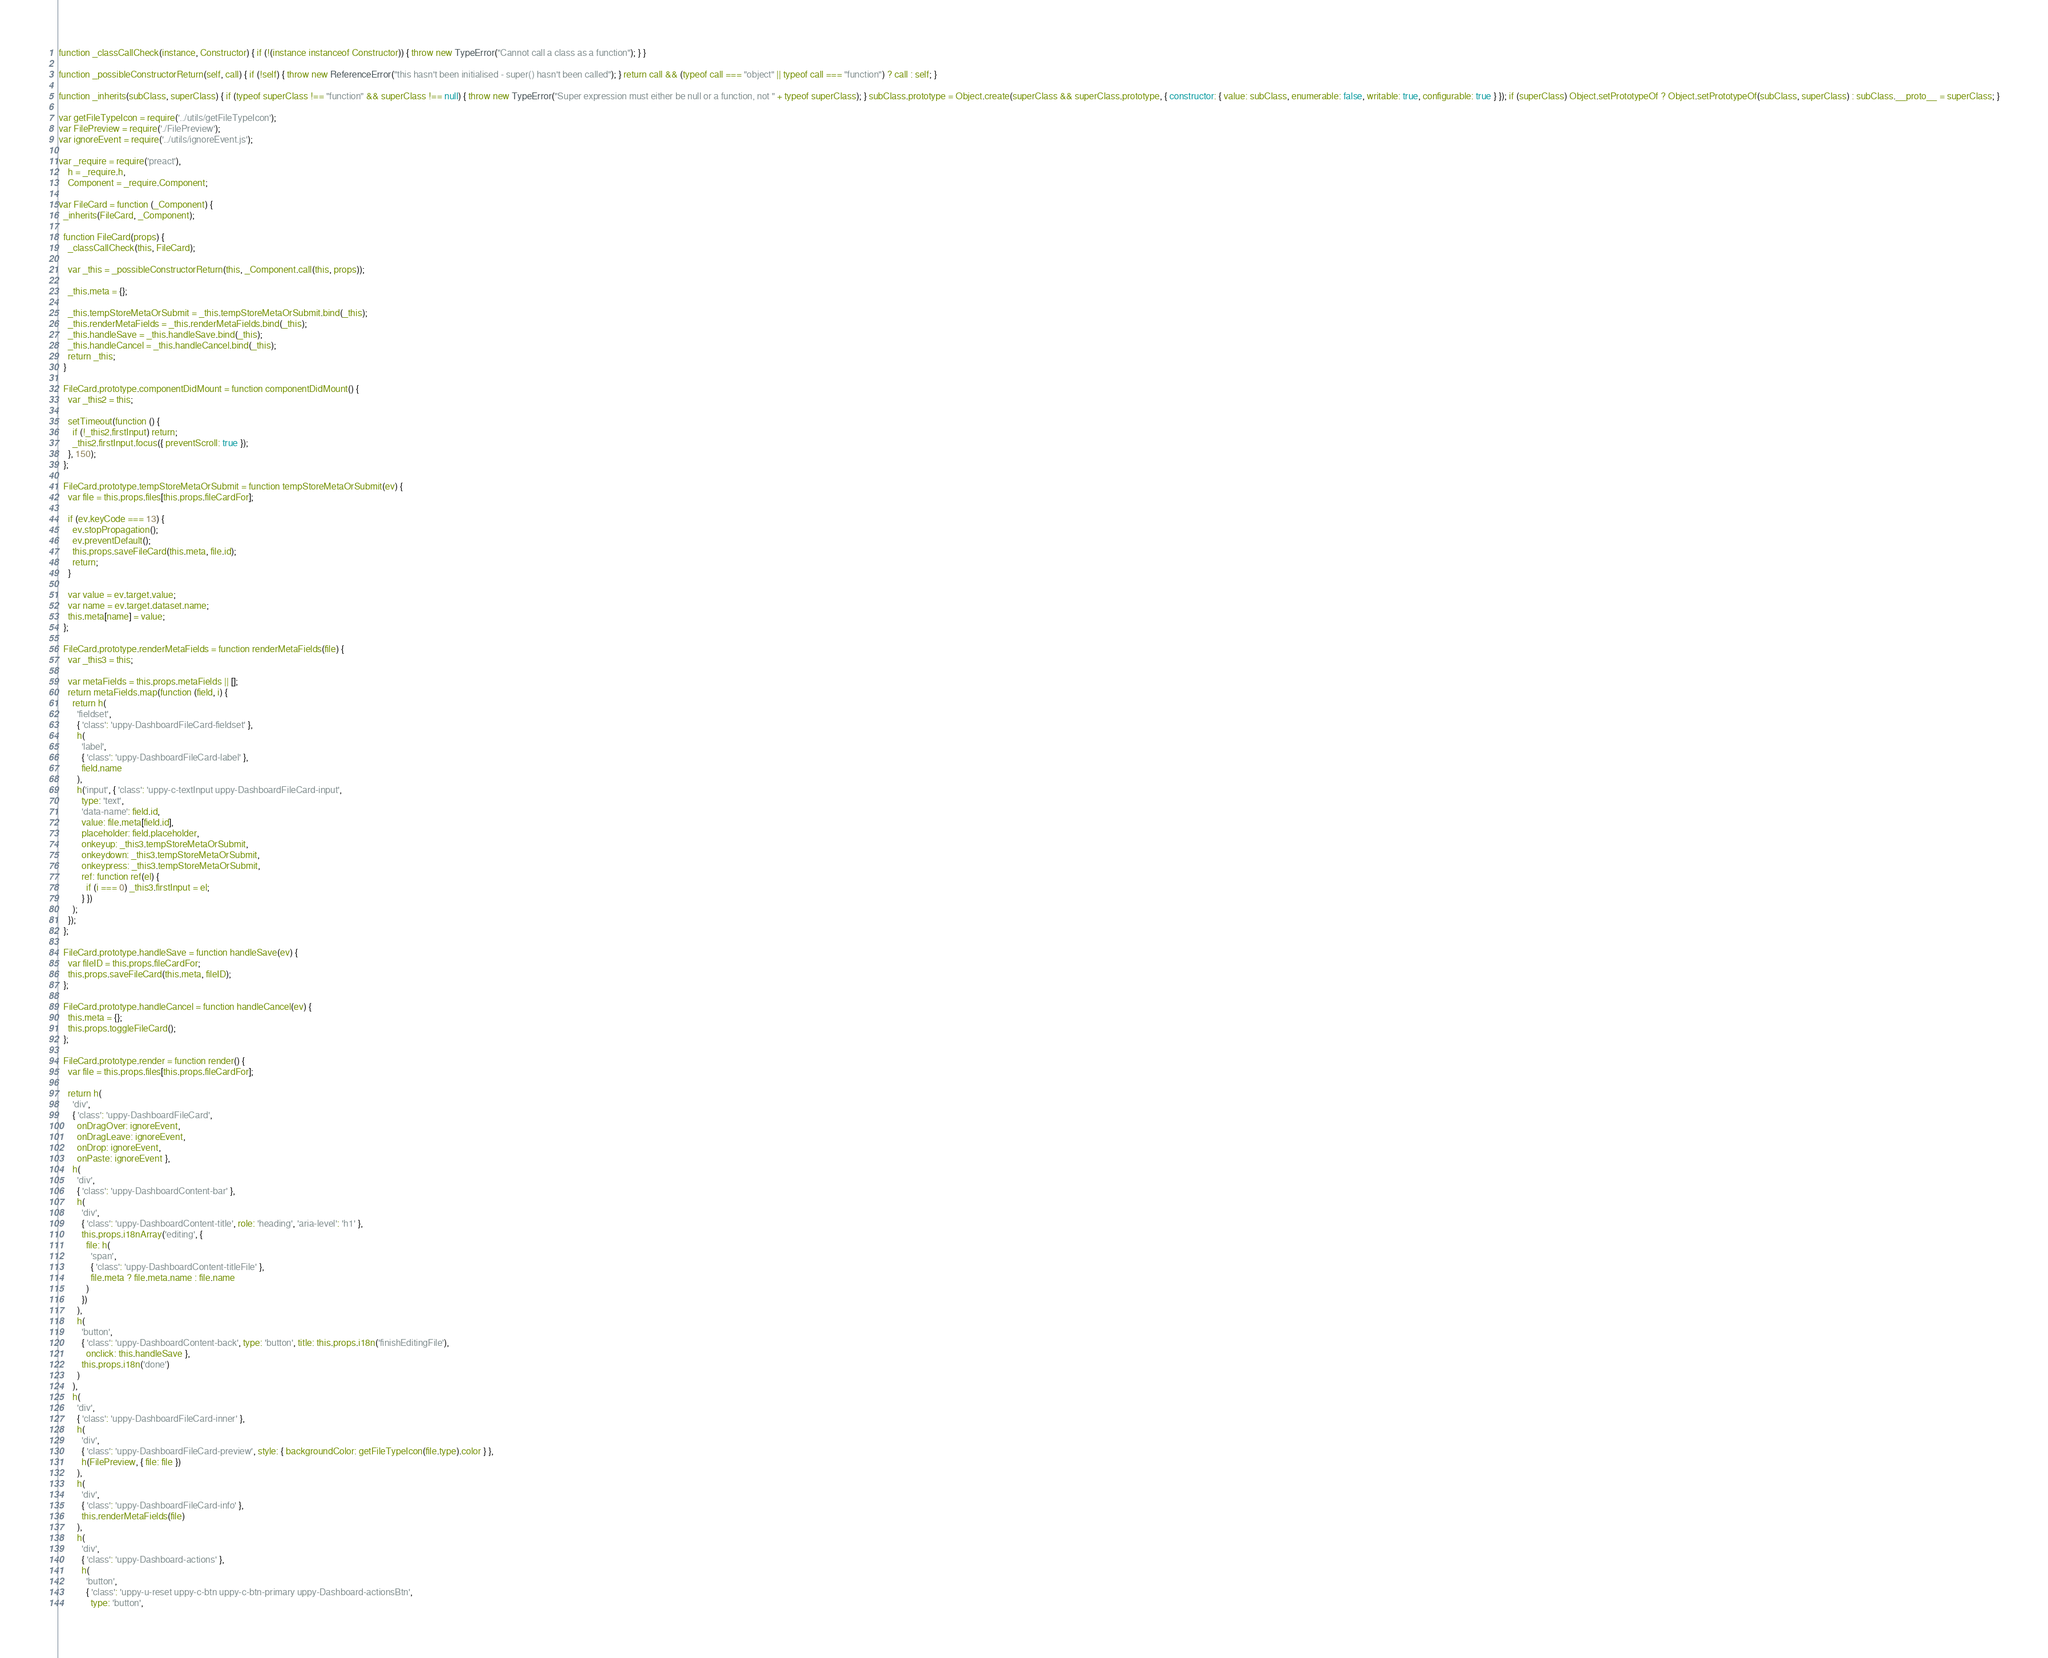Convert code to text. <code><loc_0><loc_0><loc_500><loc_500><_JavaScript_>function _classCallCheck(instance, Constructor) { if (!(instance instanceof Constructor)) { throw new TypeError("Cannot call a class as a function"); } }

function _possibleConstructorReturn(self, call) { if (!self) { throw new ReferenceError("this hasn't been initialised - super() hasn't been called"); } return call && (typeof call === "object" || typeof call === "function") ? call : self; }

function _inherits(subClass, superClass) { if (typeof superClass !== "function" && superClass !== null) { throw new TypeError("Super expression must either be null or a function, not " + typeof superClass); } subClass.prototype = Object.create(superClass && superClass.prototype, { constructor: { value: subClass, enumerable: false, writable: true, configurable: true } }); if (superClass) Object.setPrototypeOf ? Object.setPrototypeOf(subClass, superClass) : subClass.__proto__ = superClass; }

var getFileTypeIcon = require('../utils/getFileTypeIcon');
var FilePreview = require('./FilePreview');
var ignoreEvent = require('../utils/ignoreEvent.js');

var _require = require('preact'),
    h = _require.h,
    Component = _require.Component;

var FileCard = function (_Component) {
  _inherits(FileCard, _Component);

  function FileCard(props) {
    _classCallCheck(this, FileCard);

    var _this = _possibleConstructorReturn(this, _Component.call(this, props));

    _this.meta = {};

    _this.tempStoreMetaOrSubmit = _this.tempStoreMetaOrSubmit.bind(_this);
    _this.renderMetaFields = _this.renderMetaFields.bind(_this);
    _this.handleSave = _this.handleSave.bind(_this);
    _this.handleCancel = _this.handleCancel.bind(_this);
    return _this;
  }

  FileCard.prototype.componentDidMount = function componentDidMount() {
    var _this2 = this;

    setTimeout(function () {
      if (!_this2.firstInput) return;
      _this2.firstInput.focus({ preventScroll: true });
    }, 150);
  };

  FileCard.prototype.tempStoreMetaOrSubmit = function tempStoreMetaOrSubmit(ev) {
    var file = this.props.files[this.props.fileCardFor];

    if (ev.keyCode === 13) {
      ev.stopPropagation();
      ev.preventDefault();
      this.props.saveFileCard(this.meta, file.id);
      return;
    }

    var value = ev.target.value;
    var name = ev.target.dataset.name;
    this.meta[name] = value;
  };

  FileCard.prototype.renderMetaFields = function renderMetaFields(file) {
    var _this3 = this;

    var metaFields = this.props.metaFields || [];
    return metaFields.map(function (field, i) {
      return h(
        'fieldset',
        { 'class': 'uppy-DashboardFileCard-fieldset' },
        h(
          'label',
          { 'class': 'uppy-DashboardFileCard-label' },
          field.name
        ),
        h('input', { 'class': 'uppy-c-textInput uppy-DashboardFileCard-input',
          type: 'text',
          'data-name': field.id,
          value: file.meta[field.id],
          placeholder: field.placeholder,
          onkeyup: _this3.tempStoreMetaOrSubmit,
          onkeydown: _this3.tempStoreMetaOrSubmit,
          onkeypress: _this3.tempStoreMetaOrSubmit,
          ref: function ref(el) {
            if (i === 0) _this3.firstInput = el;
          } })
      );
    });
  };

  FileCard.prototype.handleSave = function handleSave(ev) {
    var fileID = this.props.fileCardFor;
    this.props.saveFileCard(this.meta, fileID);
  };

  FileCard.prototype.handleCancel = function handleCancel(ev) {
    this.meta = {};
    this.props.toggleFileCard();
  };

  FileCard.prototype.render = function render() {
    var file = this.props.files[this.props.fileCardFor];

    return h(
      'div',
      { 'class': 'uppy-DashboardFileCard',
        onDragOver: ignoreEvent,
        onDragLeave: ignoreEvent,
        onDrop: ignoreEvent,
        onPaste: ignoreEvent },
      h(
        'div',
        { 'class': 'uppy-DashboardContent-bar' },
        h(
          'div',
          { 'class': 'uppy-DashboardContent-title', role: 'heading', 'aria-level': 'h1' },
          this.props.i18nArray('editing', {
            file: h(
              'span',
              { 'class': 'uppy-DashboardContent-titleFile' },
              file.meta ? file.meta.name : file.name
            )
          })
        ),
        h(
          'button',
          { 'class': 'uppy-DashboardContent-back', type: 'button', title: this.props.i18n('finishEditingFile'),
            onclick: this.handleSave },
          this.props.i18n('done')
        )
      ),
      h(
        'div',
        { 'class': 'uppy-DashboardFileCard-inner' },
        h(
          'div',
          { 'class': 'uppy-DashboardFileCard-preview', style: { backgroundColor: getFileTypeIcon(file.type).color } },
          h(FilePreview, { file: file })
        ),
        h(
          'div',
          { 'class': 'uppy-DashboardFileCard-info' },
          this.renderMetaFields(file)
        ),
        h(
          'div',
          { 'class': 'uppy-Dashboard-actions' },
          h(
            'button',
            { 'class': 'uppy-u-reset uppy-c-btn uppy-c-btn-primary uppy-Dashboard-actionsBtn',
              type: 'button',</code> 